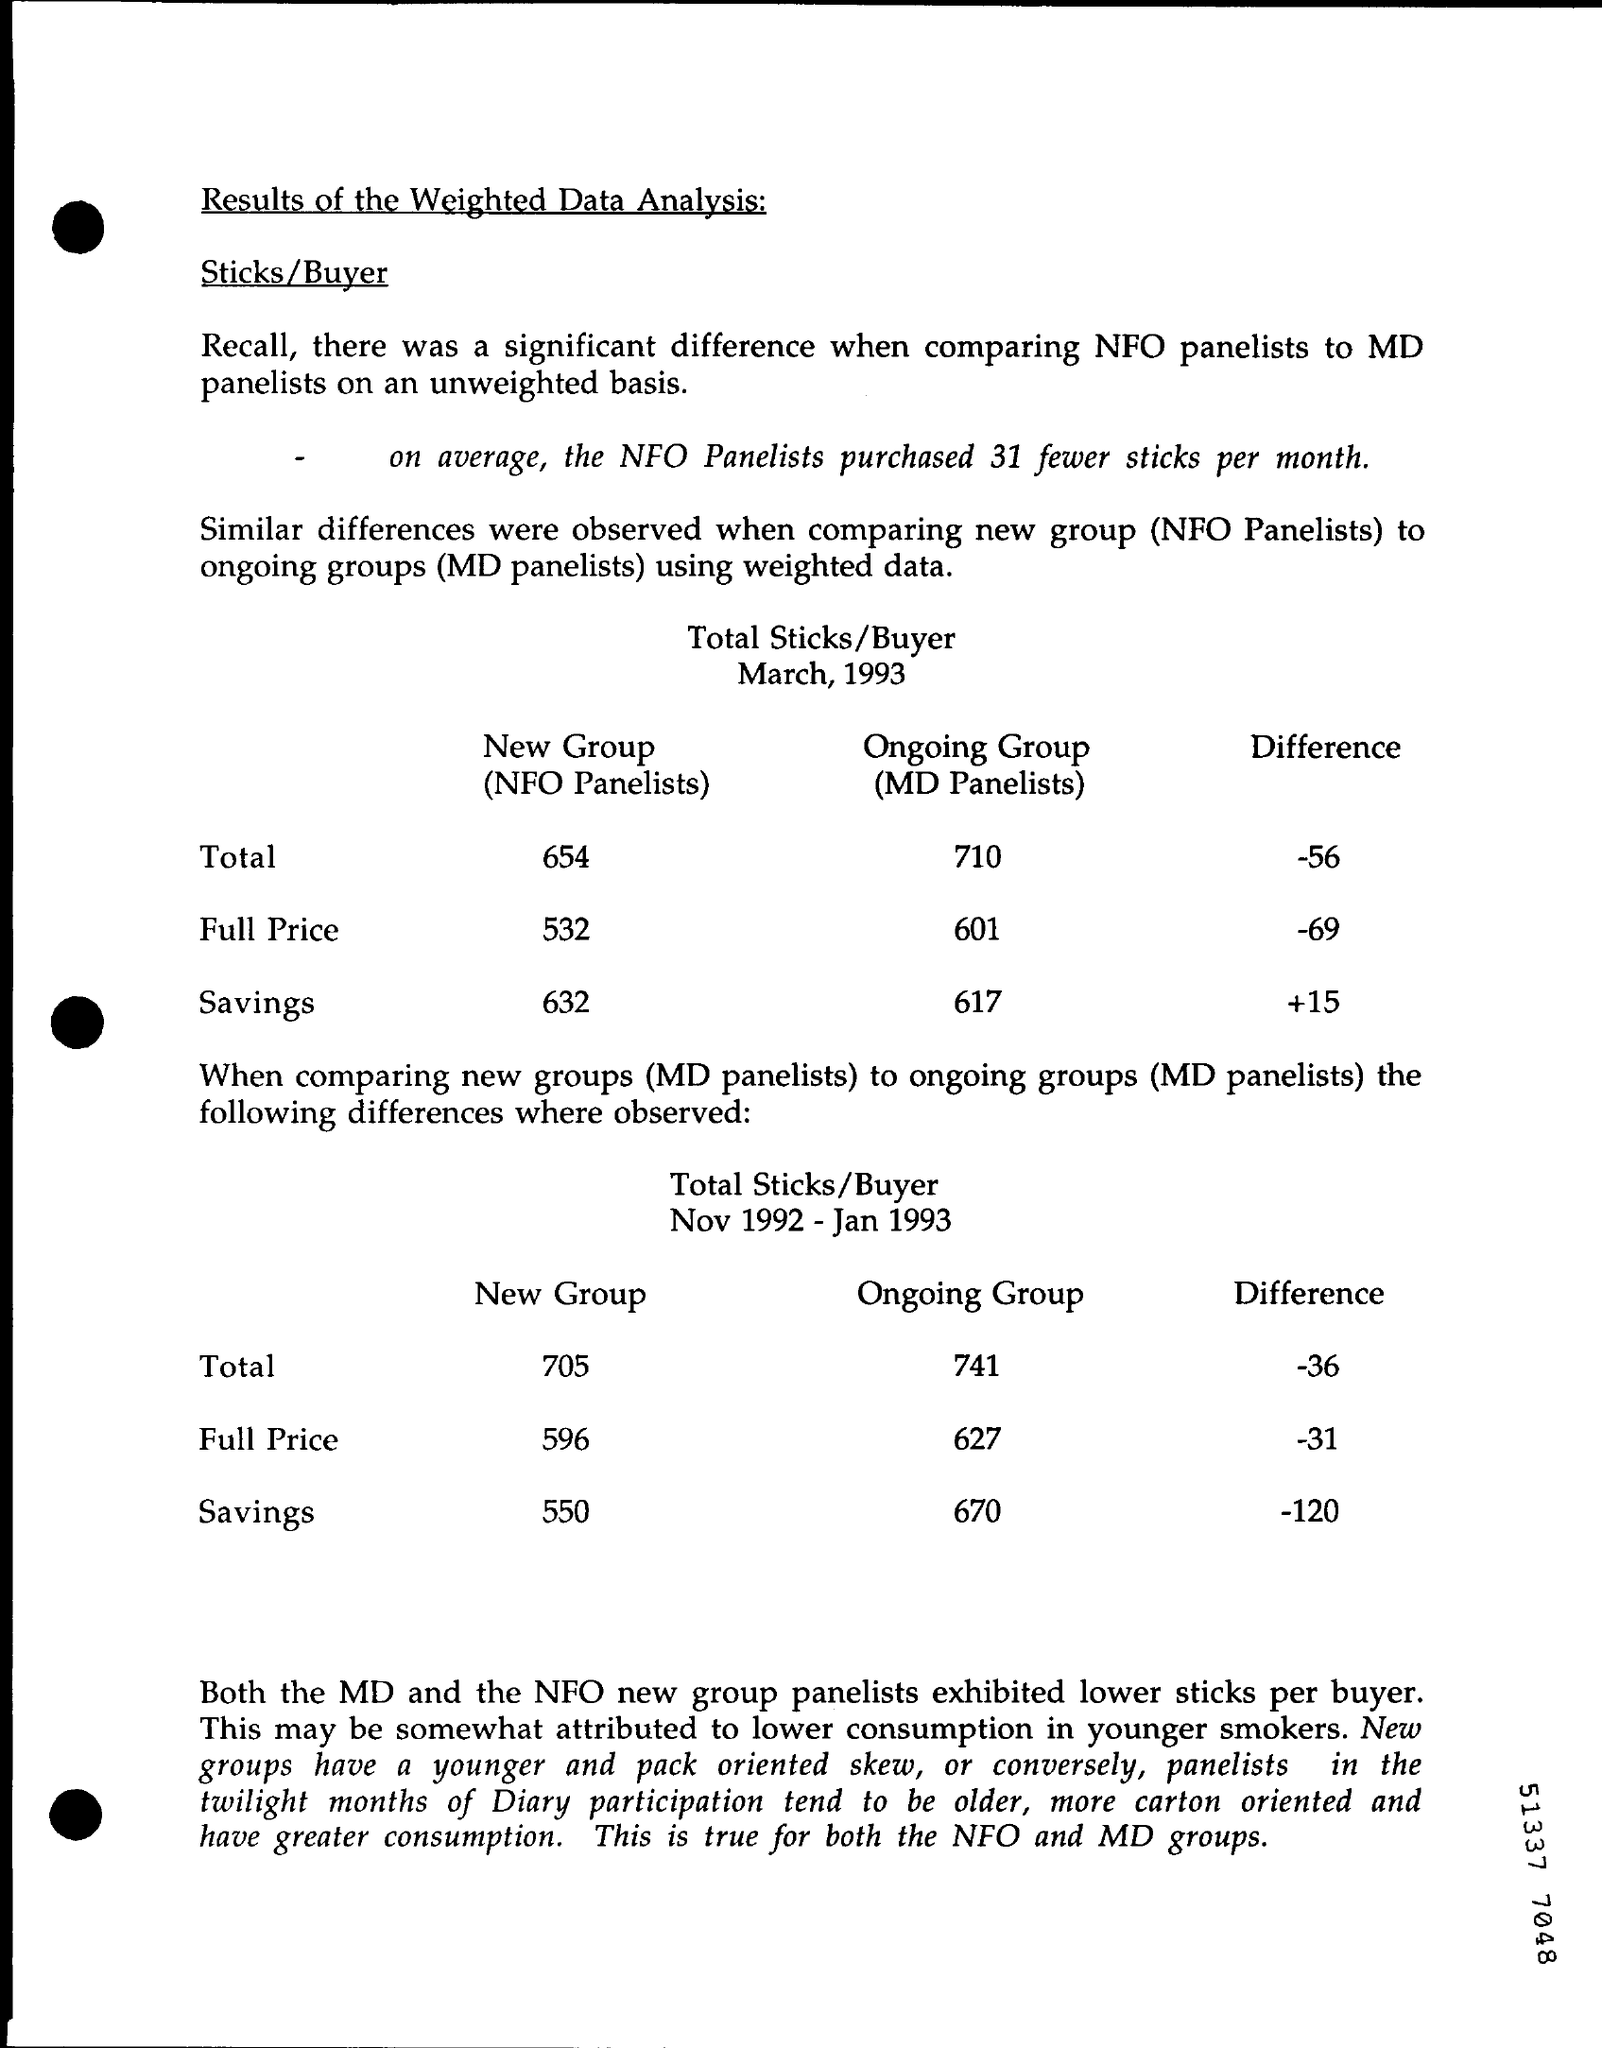Highlight a few significant elements in this photo. The total value of the new group (NFO panelists) in March 1993 was 654. The full price of an ongoing group (MD panelists) in March 1993 was $601. The difference in value between the full price from November 1992 to January 1993 was -31 dollars. On average, NFO panelists purchased fewer sticks than the control group. Specifically, 31 fewer sticks were purchased by the NFO panelists. The value of savings in March 1993 was +15. 